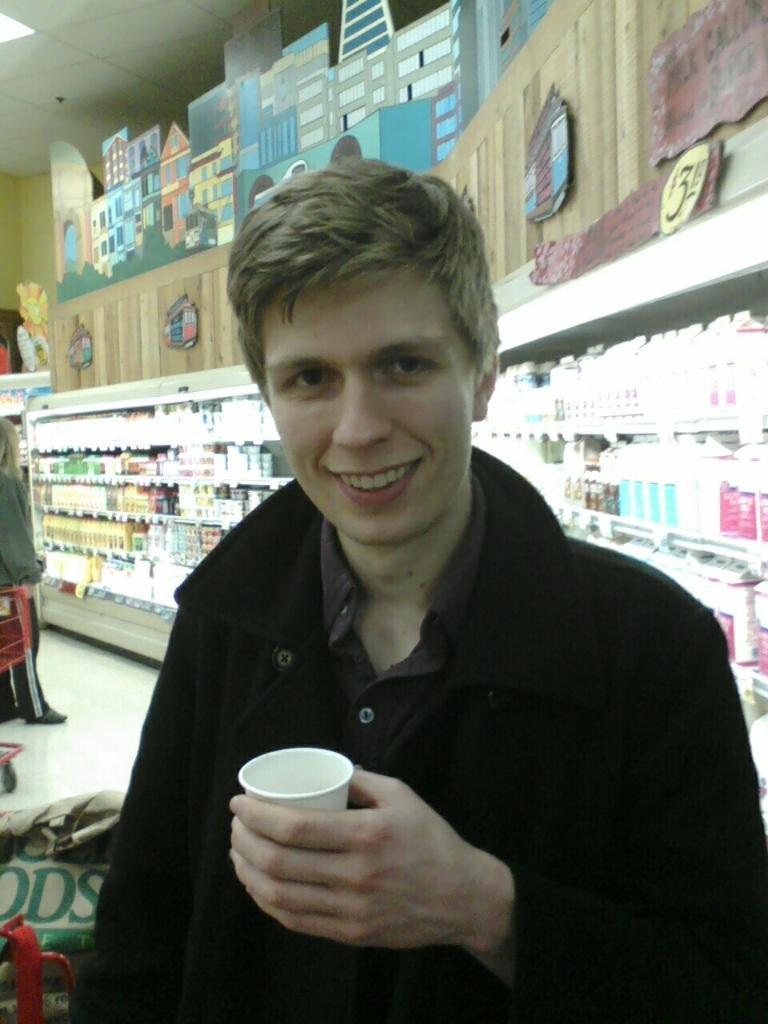Describe this image in one or two sentences. In this image we can see a person holding a glass. There are many objects placed on the racks. There is a painting at the top of the image. We can see a person standing at the left side of the image. There is a light at the left side of the image. There are few objects at the bottom of the image. 